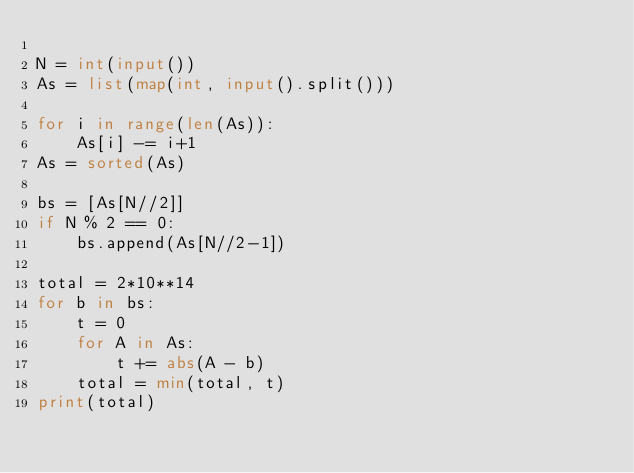Convert code to text. <code><loc_0><loc_0><loc_500><loc_500><_Python_>
N = int(input())
As = list(map(int, input().split()))

for i in range(len(As)):
    As[i] -= i+1
As = sorted(As)

bs = [As[N//2]]
if N % 2 == 0:
    bs.append(As[N//2-1])

total = 2*10**14
for b in bs:
    t = 0
    for A in As:
        t += abs(A - b)
    total = min(total, t)
print(total)</code> 